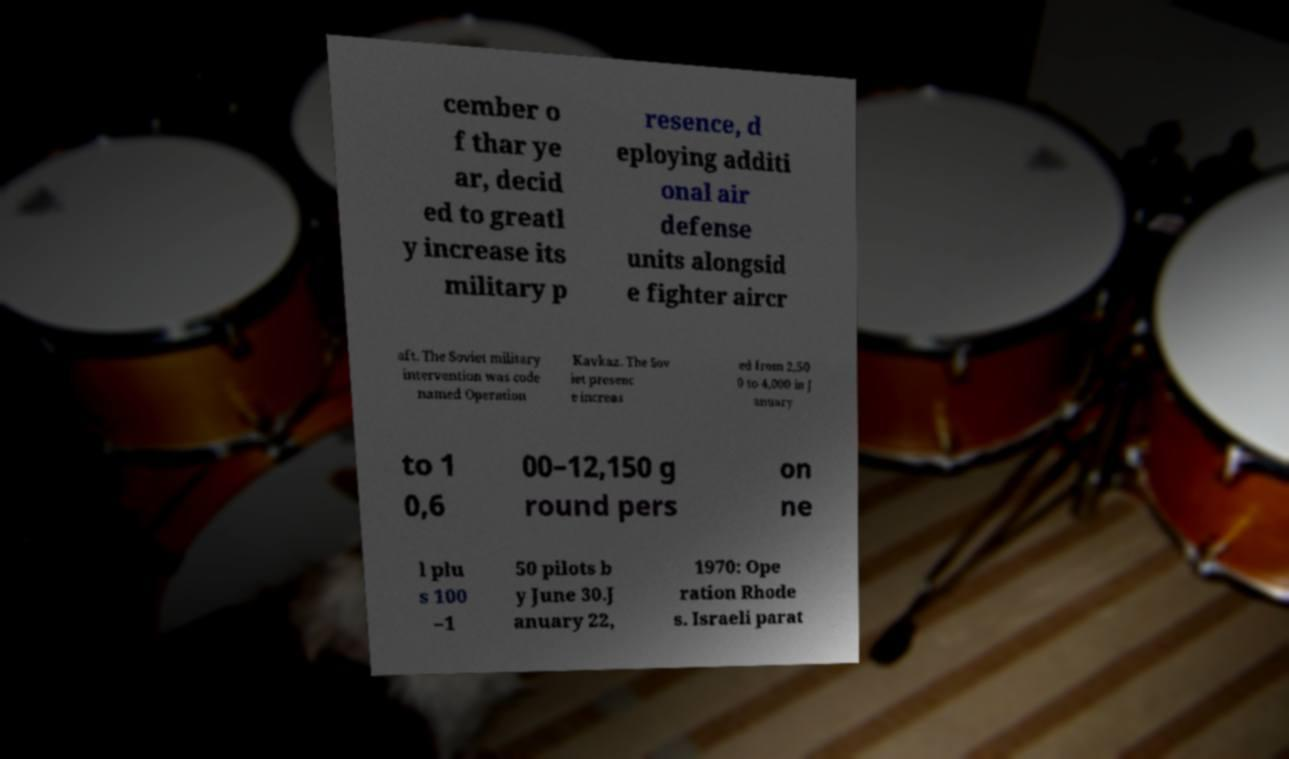Can you read and provide the text displayed in the image?This photo seems to have some interesting text. Can you extract and type it out for me? cember o f thar ye ar, decid ed to greatl y increase its military p resence, d eploying additi onal air defense units alongsid e fighter aircr aft. The Soviet military intervention was code named Operation Kavkaz. The Sov iet presenc e increas ed from 2,50 0 to 4,000 in J anuary to 1 0,6 00–12,150 g round pers on ne l plu s 100 –1 50 pilots b y June 30.J anuary 22, 1970: Ope ration Rhode s. Israeli parat 